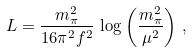Convert formula to latex. <formula><loc_0><loc_0><loc_500><loc_500>L = \frac { m _ { \pi } ^ { 2 } } { 1 6 \pi ^ { 2 } f ^ { 2 } } \, \log \left ( \frac { m _ { \pi } ^ { 2 } } { \mu ^ { 2 } } \right ) \, ,</formula> 